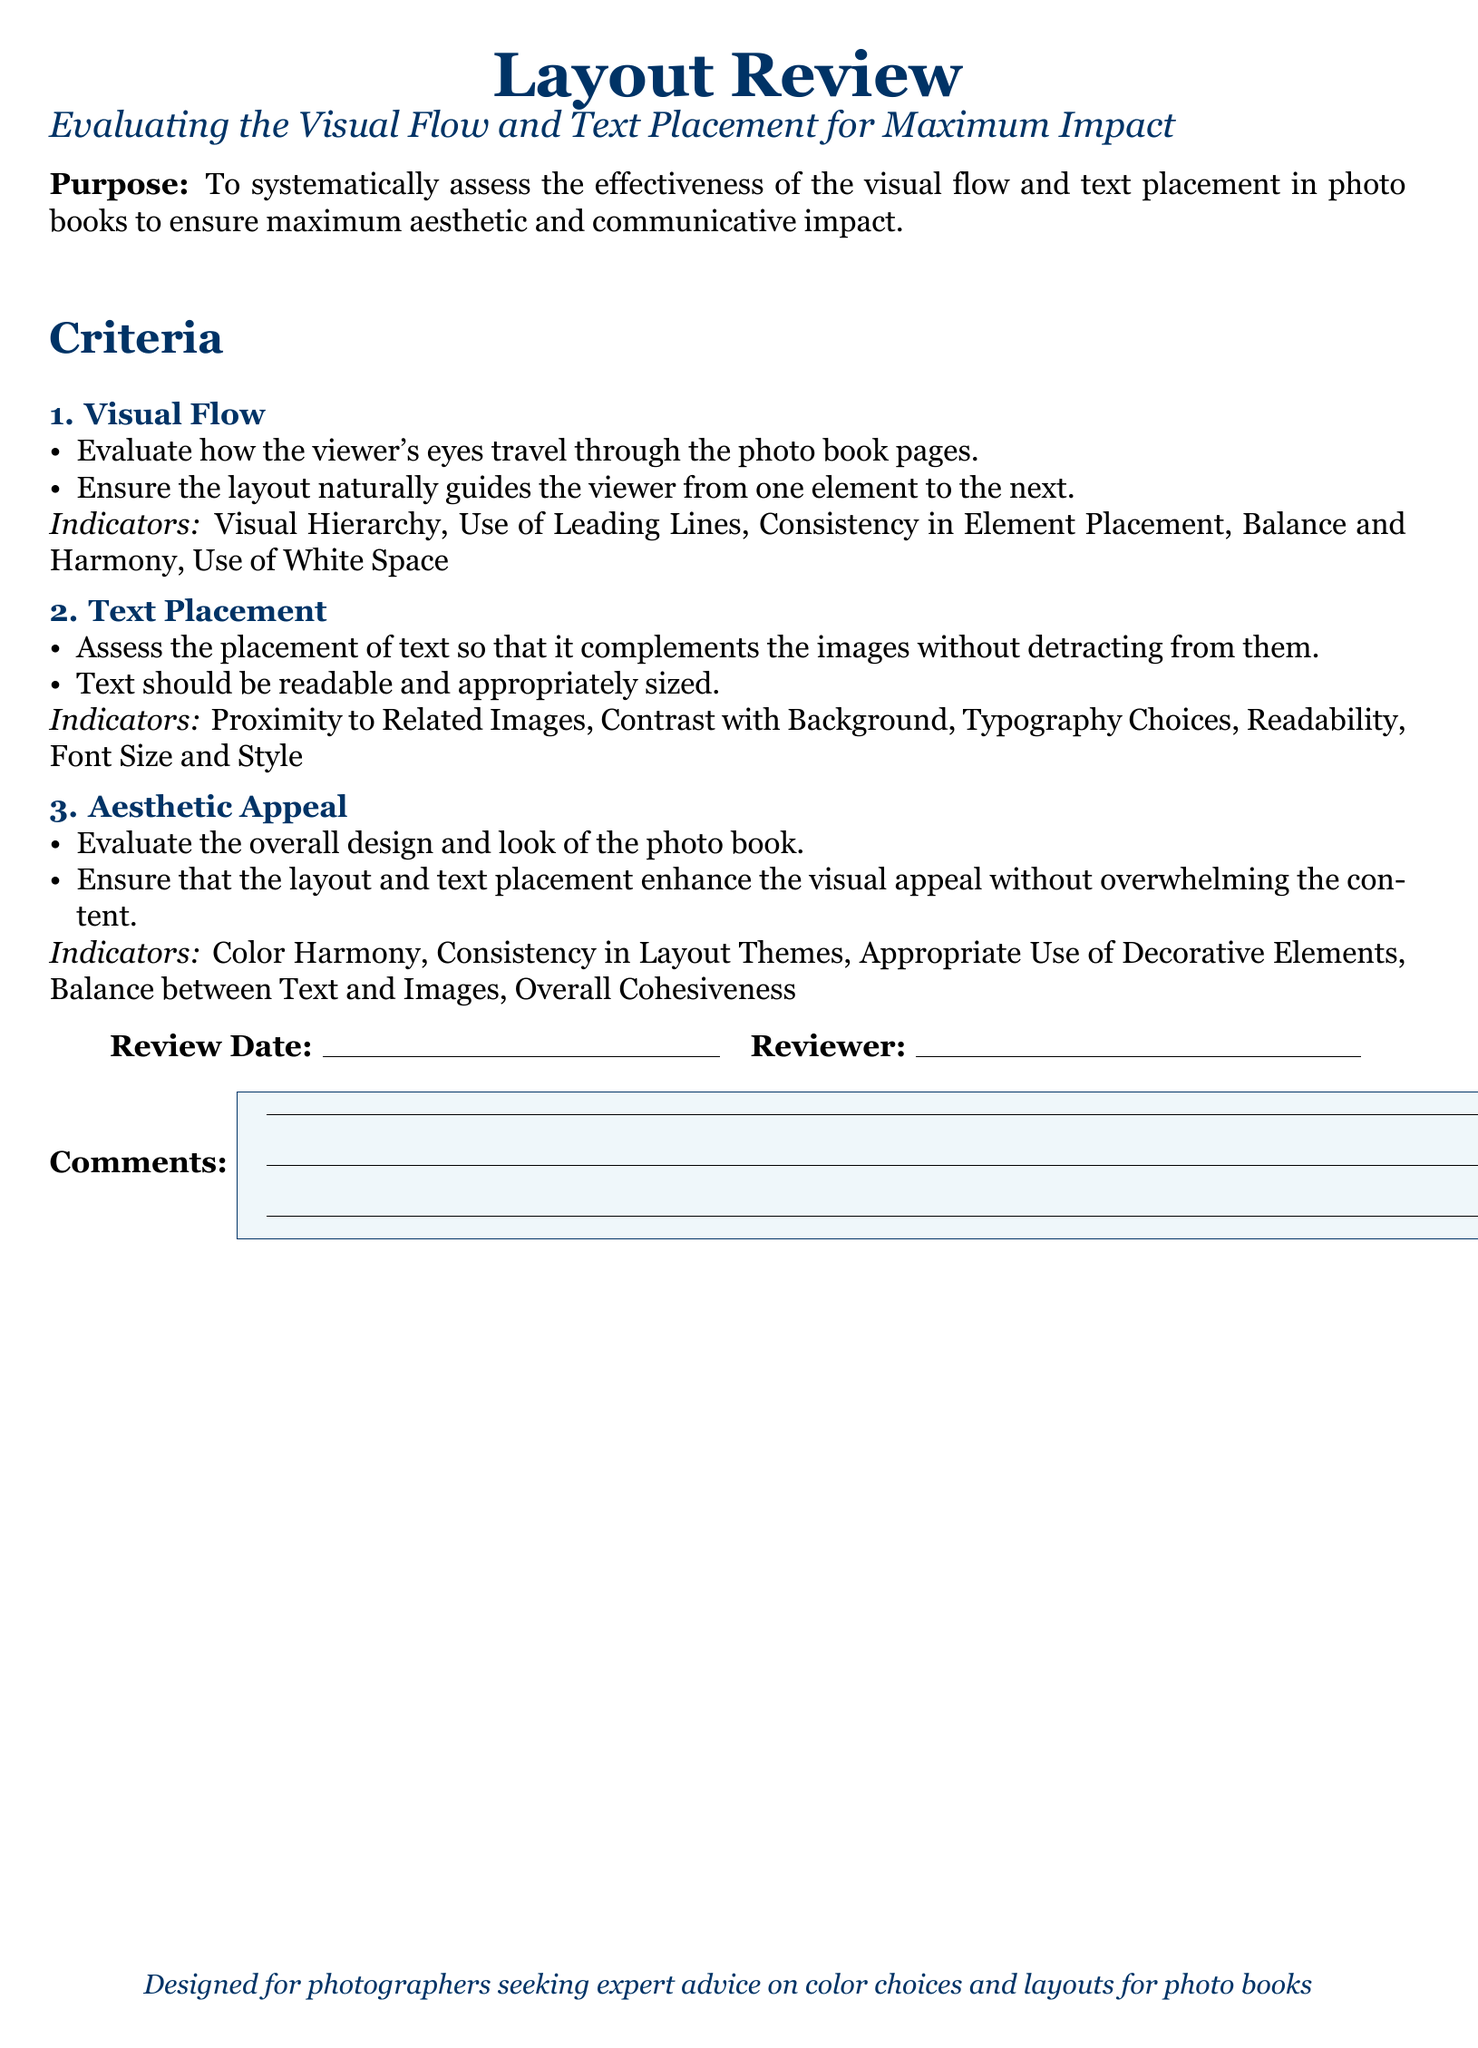What is the title of the document? The title of the document is located at the beginning and presented in a prominent format.
Answer: Layout Review What is the purpose of the document? The purpose can be found in the section describing the overall goal of the appraisal form.
Answer: To systematically assess the effectiveness of the visual flow and text placement in photo books to ensure maximum aesthetic and communicative impact What color is used for headings in the document? The color for headings is specified near the start, describing the visual design choices.
Answer: darkblue How many criteria are evaluated in the document? The criteria section lists the major aspects evaluated in the appraisal form.
Answer: 3 What is the first criterion mentioned? The first criterion can be found in the list that evaluates specific aspects of the layout.
Answer: Visual Flow What does the second criterion focus on? The second criterion's focus can be extracted directly from its section in the document.
Answer: Text Placement What type of feedback is requested in the comments section? The comments section indicates the type of input expected based on its label and available space.
Answer: General feedback What aspect of layout does the 'Aesthetic Appeal' criterion emphasize? This criterion's emphasis can be identified through its indicators section.
Answer: Overall design and look Who is the designed audience for this document? The intended audience can be found in the final statement of the document.
Answer: Photographers seeking expert advice on color choices and layouts for photo books 